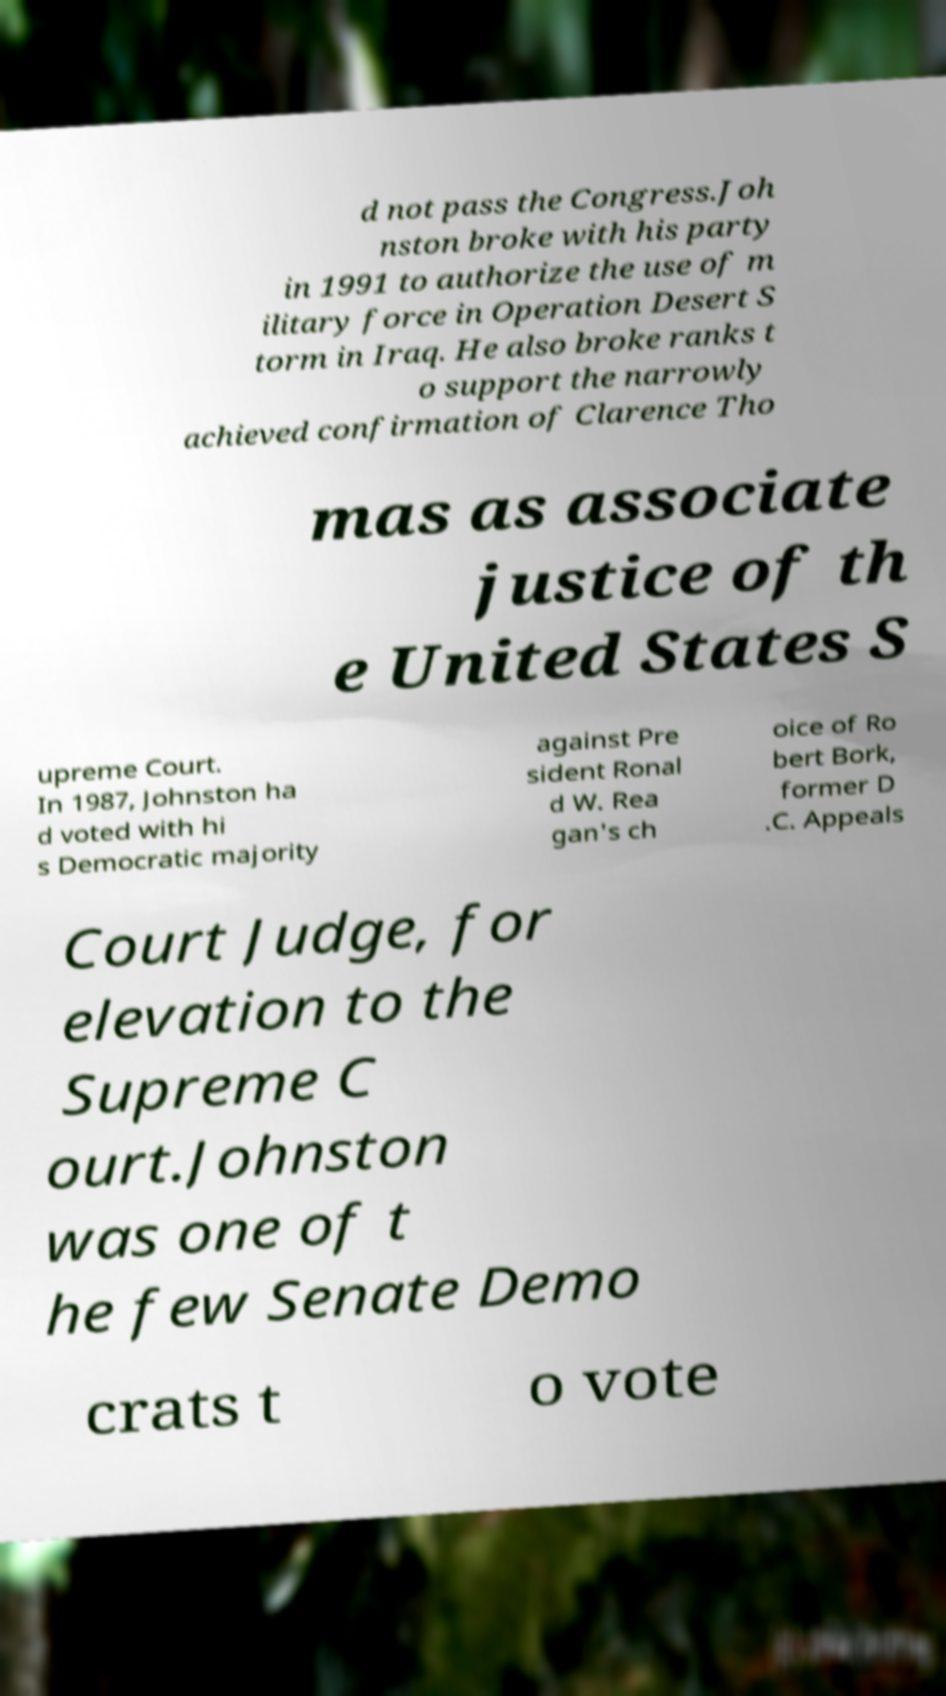I need the written content from this picture converted into text. Can you do that? d not pass the Congress.Joh nston broke with his party in 1991 to authorize the use of m ilitary force in Operation Desert S torm in Iraq. He also broke ranks t o support the narrowly achieved confirmation of Clarence Tho mas as associate justice of th e United States S upreme Court. In 1987, Johnston ha d voted with hi s Democratic majority against Pre sident Ronal d W. Rea gan's ch oice of Ro bert Bork, former D .C. Appeals Court Judge, for elevation to the Supreme C ourt.Johnston was one of t he few Senate Demo crats t o vote 